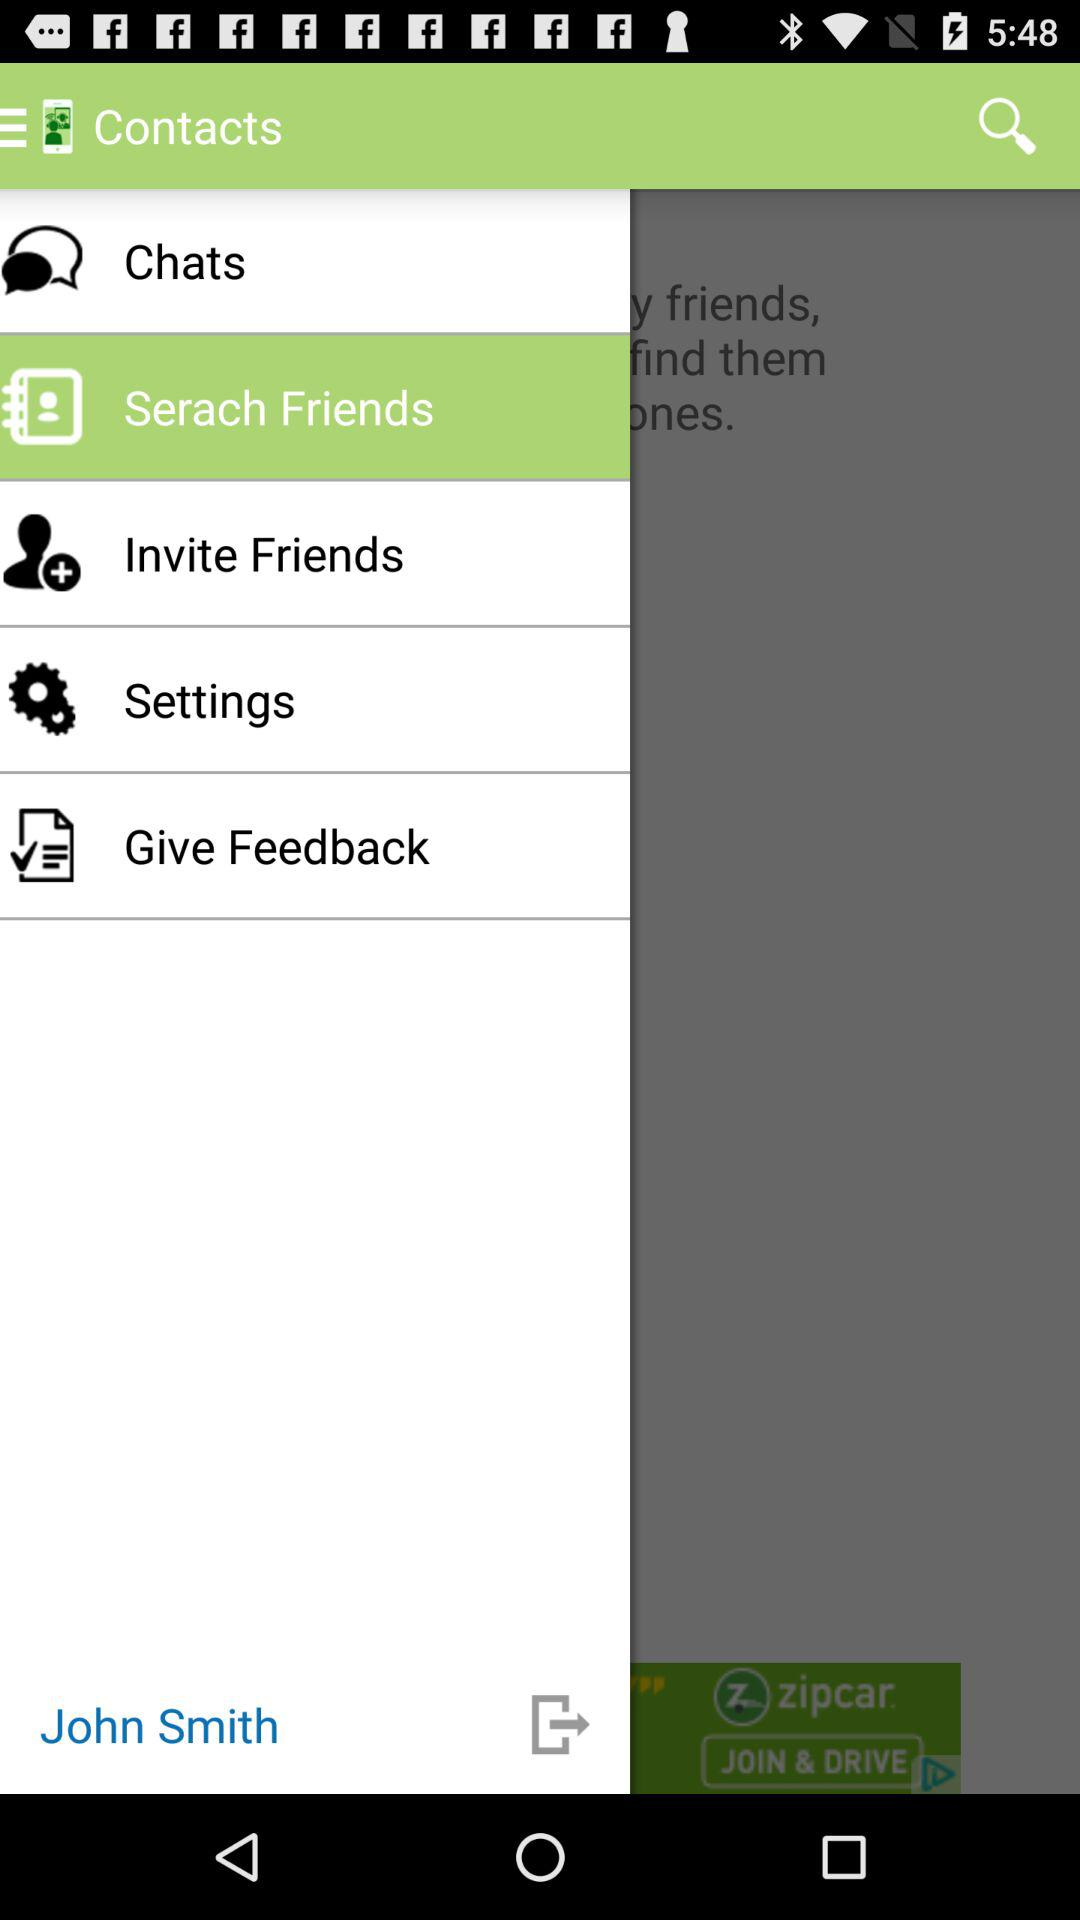What is the user name? The user name is John Smith. 